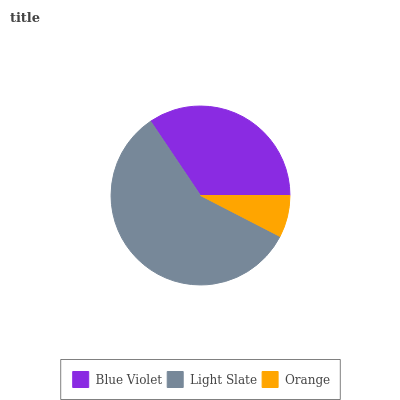Is Orange the minimum?
Answer yes or no. Yes. Is Light Slate the maximum?
Answer yes or no. Yes. Is Light Slate the minimum?
Answer yes or no. No. Is Orange the maximum?
Answer yes or no. No. Is Light Slate greater than Orange?
Answer yes or no. Yes. Is Orange less than Light Slate?
Answer yes or no. Yes. Is Orange greater than Light Slate?
Answer yes or no. No. Is Light Slate less than Orange?
Answer yes or no. No. Is Blue Violet the high median?
Answer yes or no. Yes. Is Blue Violet the low median?
Answer yes or no. Yes. Is Light Slate the high median?
Answer yes or no. No. Is Orange the low median?
Answer yes or no. No. 